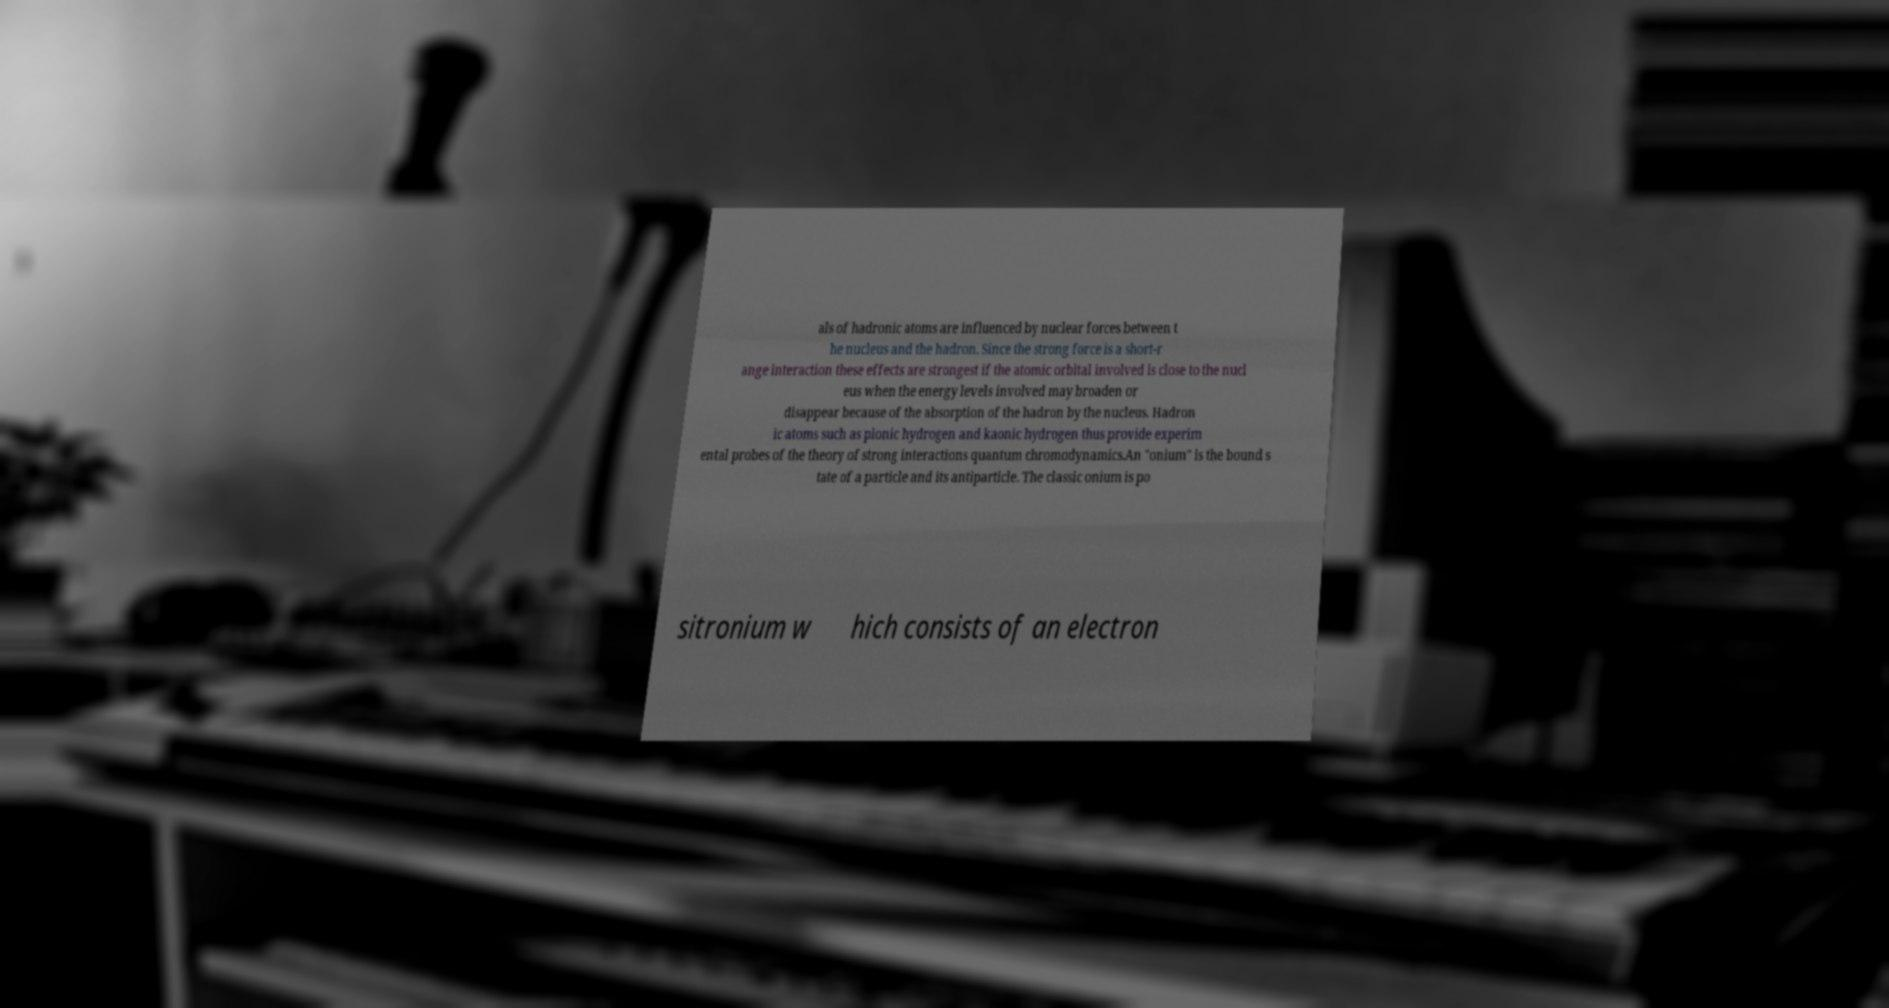Can you read and provide the text displayed in the image?This photo seems to have some interesting text. Can you extract and type it out for me? als of hadronic atoms are influenced by nuclear forces between t he nucleus and the hadron. Since the strong force is a short-r ange interaction these effects are strongest if the atomic orbital involved is close to the nucl eus when the energy levels involved may broaden or disappear because of the absorption of the hadron by the nucleus. Hadron ic atoms such as pionic hydrogen and kaonic hydrogen thus provide experim ental probes of the theory of strong interactions quantum chromodynamics.An "onium" is the bound s tate of a particle and its antiparticle. The classic onium is po sitronium w hich consists of an electron 